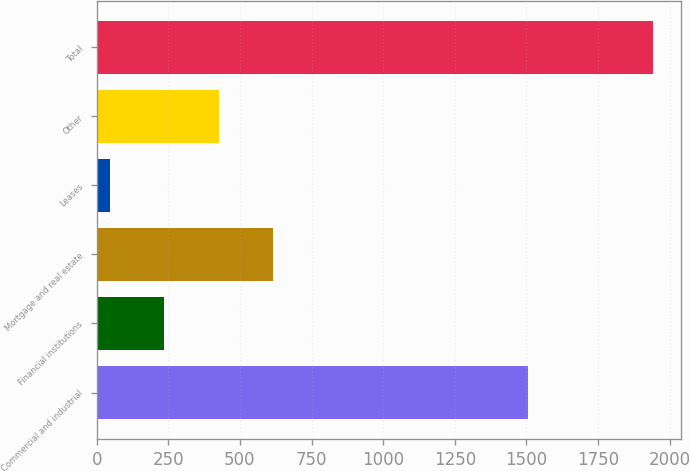Convert chart. <chart><loc_0><loc_0><loc_500><loc_500><bar_chart><fcel>Commercial and industrial<fcel>Financial institutions<fcel>Mortgage and real estate<fcel>Leases<fcel>Other<fcel>Total<nl><fcel>1506<fcel>235.6<fcel>614.8<fcel>46<fcel>425.2<fcel>1942<nl></chart> 